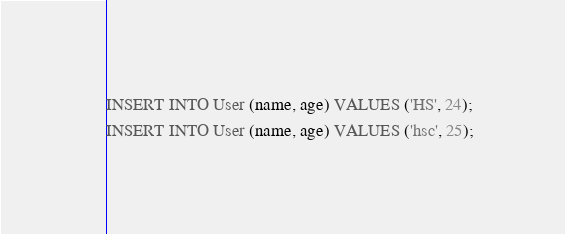Convert code to text. <code><loc_0><loc_0><loc_500><loc_500><_SQL_>INSERT INTO User (name, age) VALUES ('HS', 24);
INSERT INTO User (name, age) VALUES ('hsc', 25);</code> 